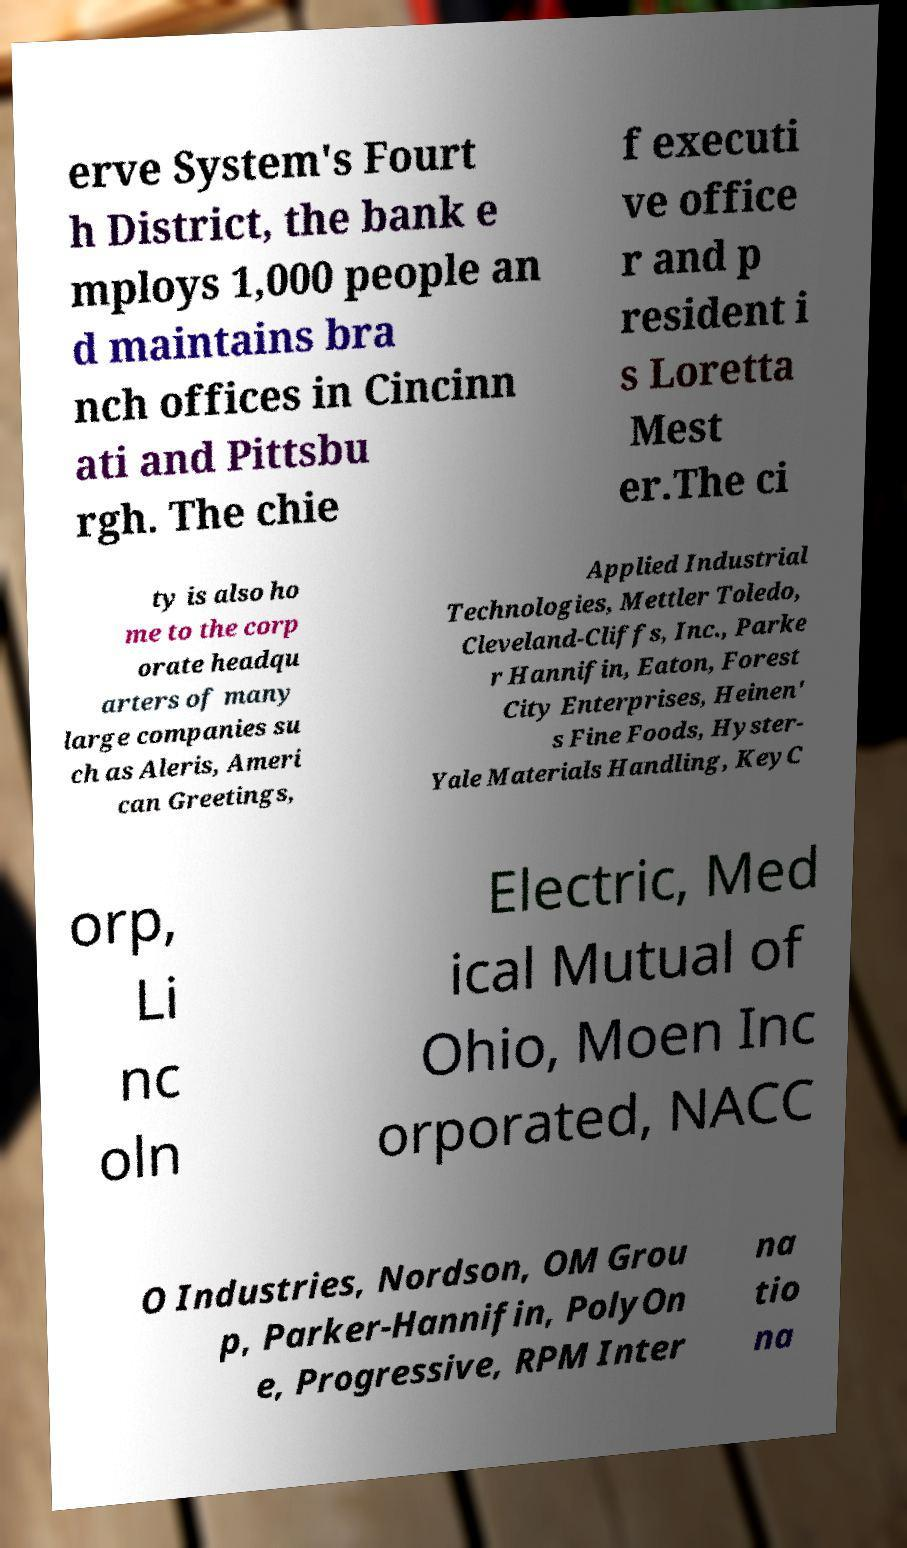Can you read and provide the text displayed in the image?This photo seems to have some interesting text. Can you extract and type it out for me? erve System's Fourt h District, the bank e mploys 1,000 people an d maintains bra nch offices in Cincinn ati and Pittsbu rgh. The chie f executi ve office r and p resident i s Loretta Mest er.The ci ty is also ho me to the corp orate headqu arters of many large companies su ch as Aleris, Ameri can Greetings, Applied Industrial Technologies, Mettler Toledo, Cleveland-Cliffs, Inc., Parke r Hannifin, Eaton, Forest City Enterprises, Heinen' s Fine Foods, Hyster- Yale Materials Handling, KeyC orp, Li nc oln Electric, Med ical Mutual of Ohio, Moen Inc orporated, NACC O Industries, Nordson, OM Grou p, Parker-Hannifin, PolyOn e, Progressive, RPM Inter na tio na 